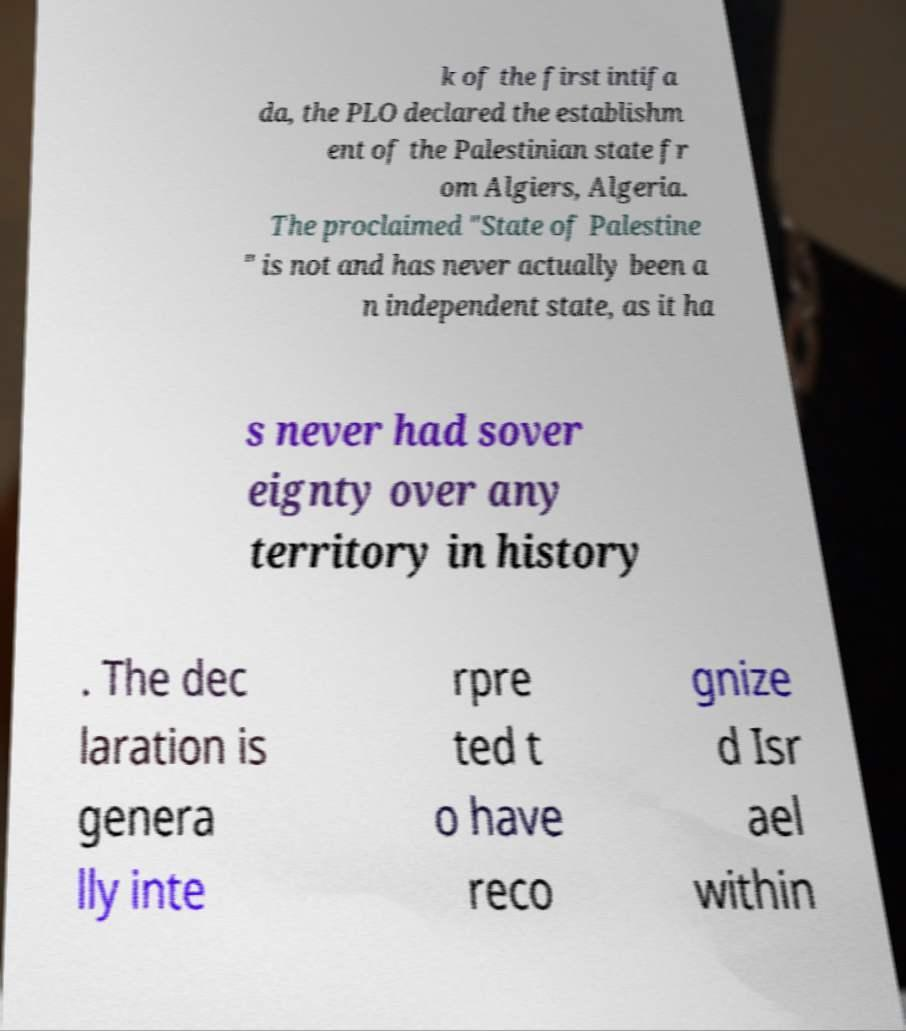Can you read and provide the text displayed in the image?This photo seems to have some interesting text. Can you extract and type it out for me? k of the first intifa da, the PLO declared the establishm ent of the Palestinian state fr om Algiers, Algeria. The proclaimed "State of Palestine " is not and has never actually been a n independent state, as it ha s never had sover eignty over any territory in history . The dec laration is genera lly inte rpre ted t o have reco gnize d Isr ael within 